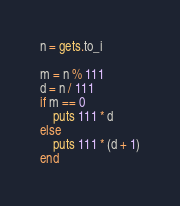Convert code to text. <code><loc_0><loc_0><loc_500><loc_500><_Ruby_>n = gets.to_i

m = n % 111
d = n / 111
if m == 0
    puts 111 * d
else
    puts 111 * (d + 1)
end

</code> 